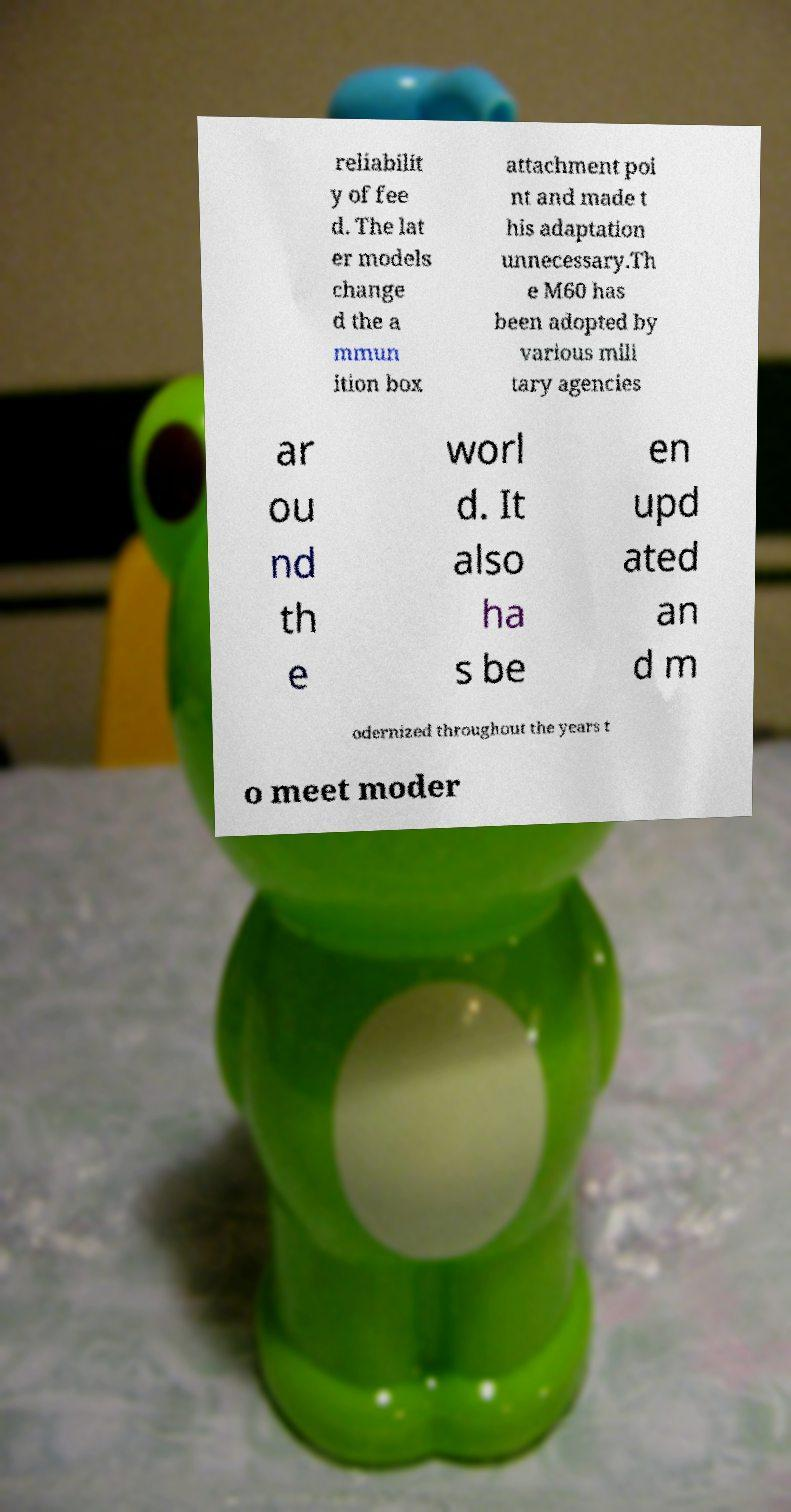Please identify and transcribe the text found in this image. reliabilit y of fee d. The lat er models change d the a mmun ition box attachment poi nt and made t his adaptation unnecessary.Th e M60 has been adopted by various mili tary agencies ar ou nd th e worl d. It also ha s be en upd ated an d m odernized throughout the years t o meet moder 